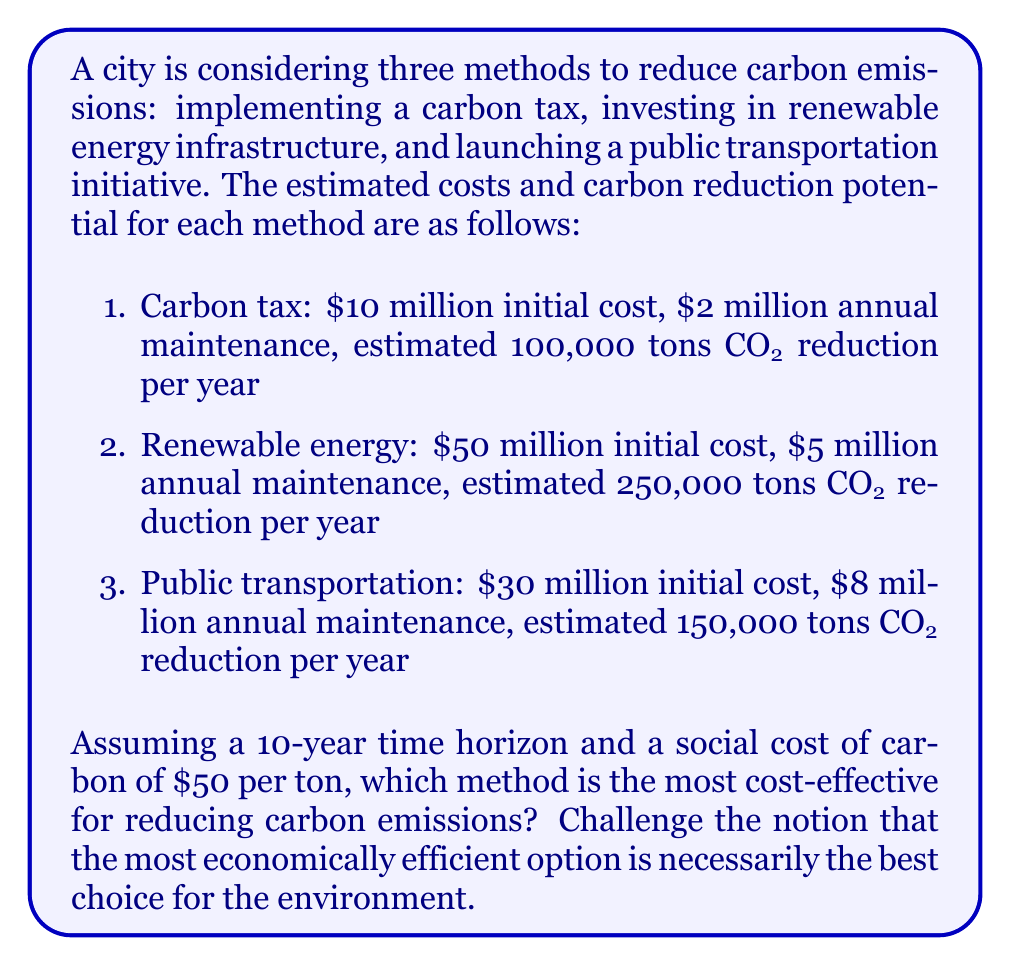Could you help me with this problem? To solve this problem, we need to calculate the cost-effectiveness of each method over the 10-year period. We'll do this by comparing the total cost of each method to its total carbon reduction.

For each method, we'll calculate:
1. Total cost over 10 years = Initial cost + (Annual maintenance × 10 years)
2. Total carbon reduction over 10 years = Annual reduction × 10 years
3. Cost per ton of CO₂ reduced = Total cost / Total carbon reduction

Let's calculate for each method:

1. Carbon tax:
   Total cost = $10M + ($2M × 10) = $30M
   Total reduction = 100,000 tons/year × 10 years = 1,000,000 tons
   Cost per ton = $30M / 1,000,000 tons = $30/ton

2. Renewable energy:
   Total cost = $50M + ($5M × 10) = $100M
   Total reduction = 250,000 tons/year × 10 years = 2,500,000 tons
   Cost per ton = $100M / 2,500,000 tons = $40/ton

3. Public transportation:
   Total cost = $30M + ($8M × 10) = $110M
   Total reduction = 150,000 tons/year × 10 years = 1,500,000 tons
   Cost per ton = $110M / 1,500,000 tons = $73.33/ton

From a purely cost-effectiveness standpoint, the carbon tax appears to be the most economically efficient option at $30 per ton of CO₂ reduced.

However, as an environmental activist, we should challenge this conclusion:

1. The carbon tax, while cost-effective, has the lowest total carbon reduction (1,000,000 tons) compared to the other options.
2. Renewable energy, while slightly more expensive per ton ($40/ton), provides the highest total carbon reduction (2,500,000 tons) and creates long-term sustainable infrastructure.
3. Public transportation, although the least cost-effective, provides additional benefits such as reduced traffic congestion and improved air quality, which are not captured in this simple analysis.

We can calculate the net benefit of each option using the social cost of carbon ($50/ton):

1. Carbon tax: 
   Net benefit = ($50/ton × 1,000,000 tons) - $30M = $20M

2. Renewable energy:
   Net benefit = ($50/ton × 2,500,000 tons) - $100M = $25M

3. Public transportation:
   Net benefit = ($50/ton × 1,500,000 tons) - $110M = -$35M

While the renewable energy option has the highest net benefit, it's crucial to consider factors beyond just economic efficiency, such as long-term environmental impact, scalability, and additional societal benefits.
Answer: From a purely cost-effectiveness standpoint, the carbon tax is the most economically efficient option at $30 per ton of CO₂ reduced. However, considering the total carbon reduction and long-term environmental impact, the renewable energy option may be the best choice, as it provides the highest total carbon reduction (2,500,000 tons) and the highest net benefit ($25M) when factoring in the social cost of carbon. As an environmental activist, it's important to emphasize that the most economically efficient option isn't always the best for the environment, and we should consider broader impacts and long-term sustainability in decision-making. 